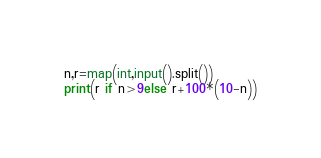<code> <loc_0><loc_0><loc_500><loc_500><_Cython_>n,r=map(int,input().split())
print(r if n>9else r+100*(10-n))</code> 